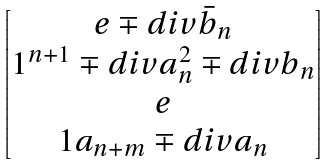Convert formula to latex. <formula><loc_0><loc_0><loc_500><loc_500>\begin{bmatrix} e \mp d i v \bar { b } _ { n } \\ 1 ^ { n + 1 } \mp d i v a _ { n } ^ { 2 } \mp d i v b _ { n } \\ e \\ 1 a _ { n + m } \mp d i v a _ { n } \end{bmatrix}</formula> 